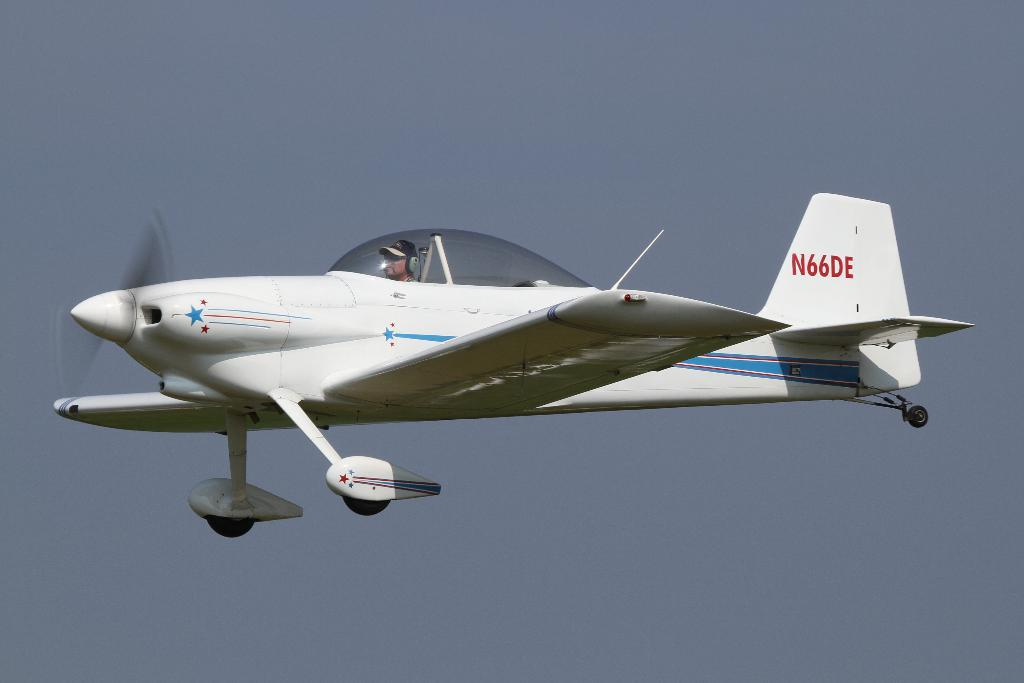Who is the main subject in the image? There is a person in the image. What is the person doing in the image? The person is riding a plane. Can you describe the plane's location in the image? The plane is in the air. Are there any fairies flying around the plane in the image? There are no fairies present in the image. What type of mountain can be seen in the background of the image? There is no mountain visible in the image; it features a person riding a plane in the air. 